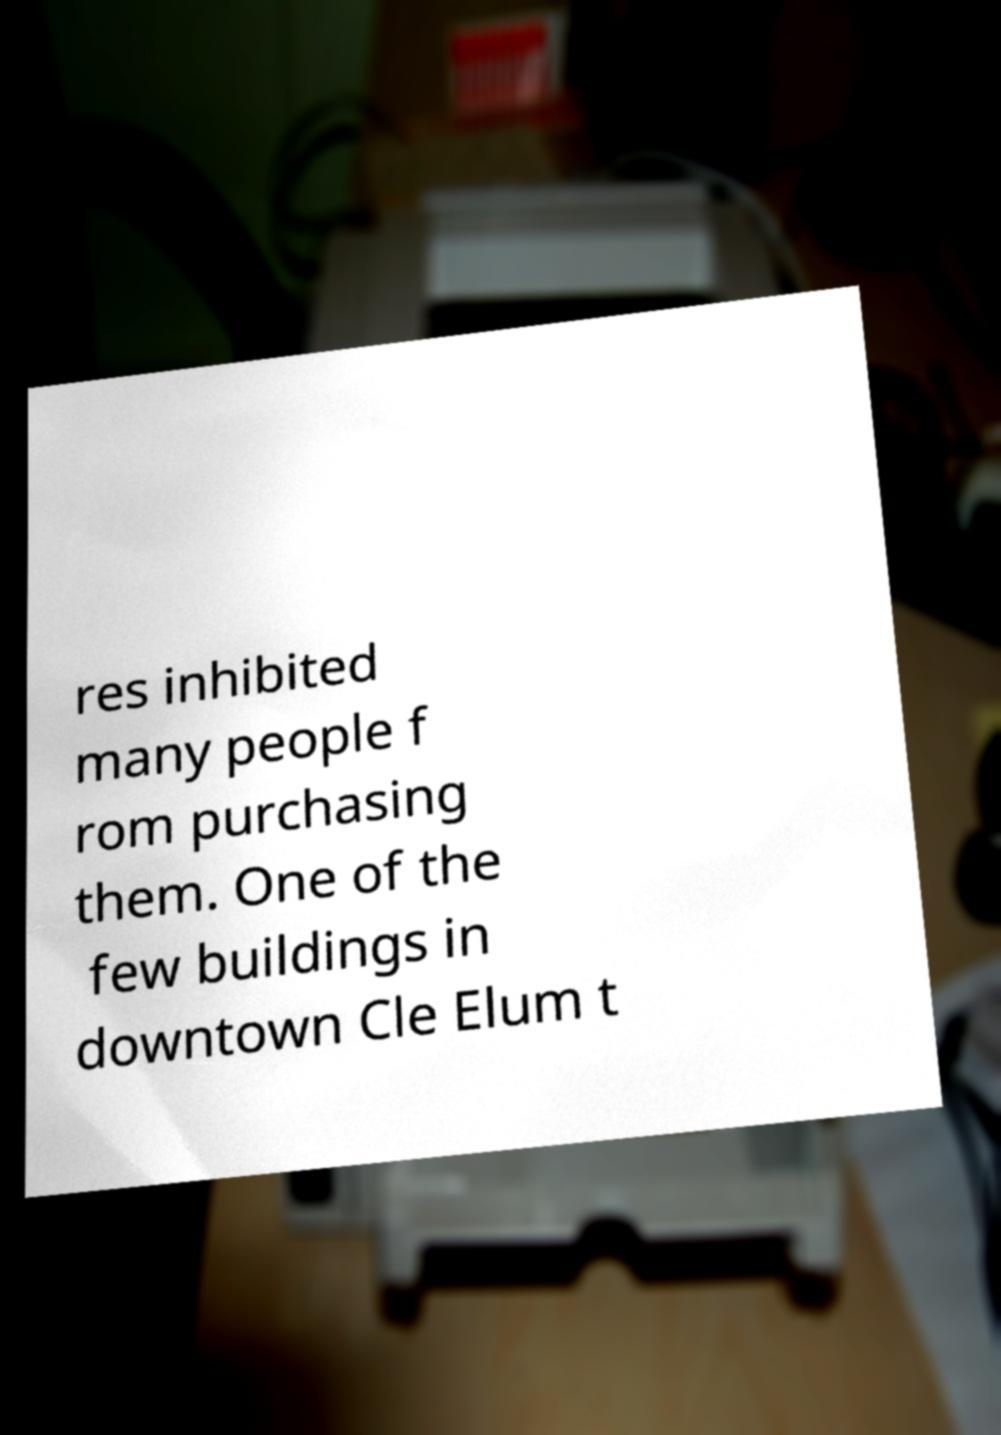For documentation purposes, I need the text within this image transcribed. Could you provide that? res inhibited many people f rom purchasing them. One of the few buildings in downtown Cle Elum t 